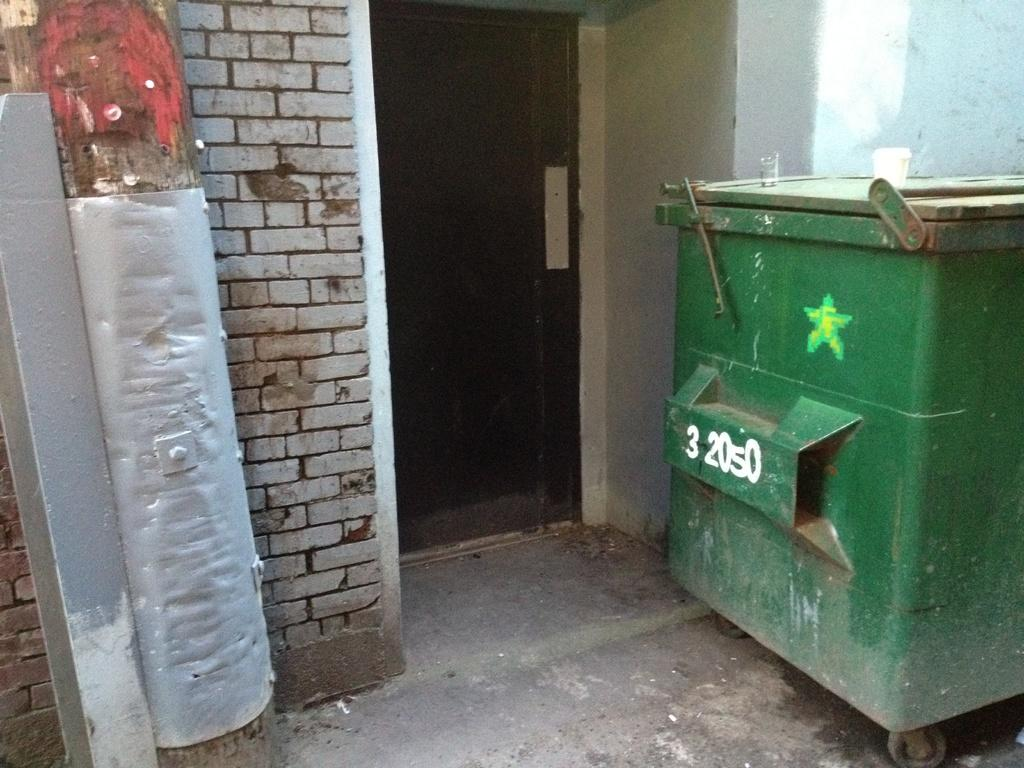<image>
Relay a brief, clear account of the picture shown. the number 3 is on the green trash can outside 